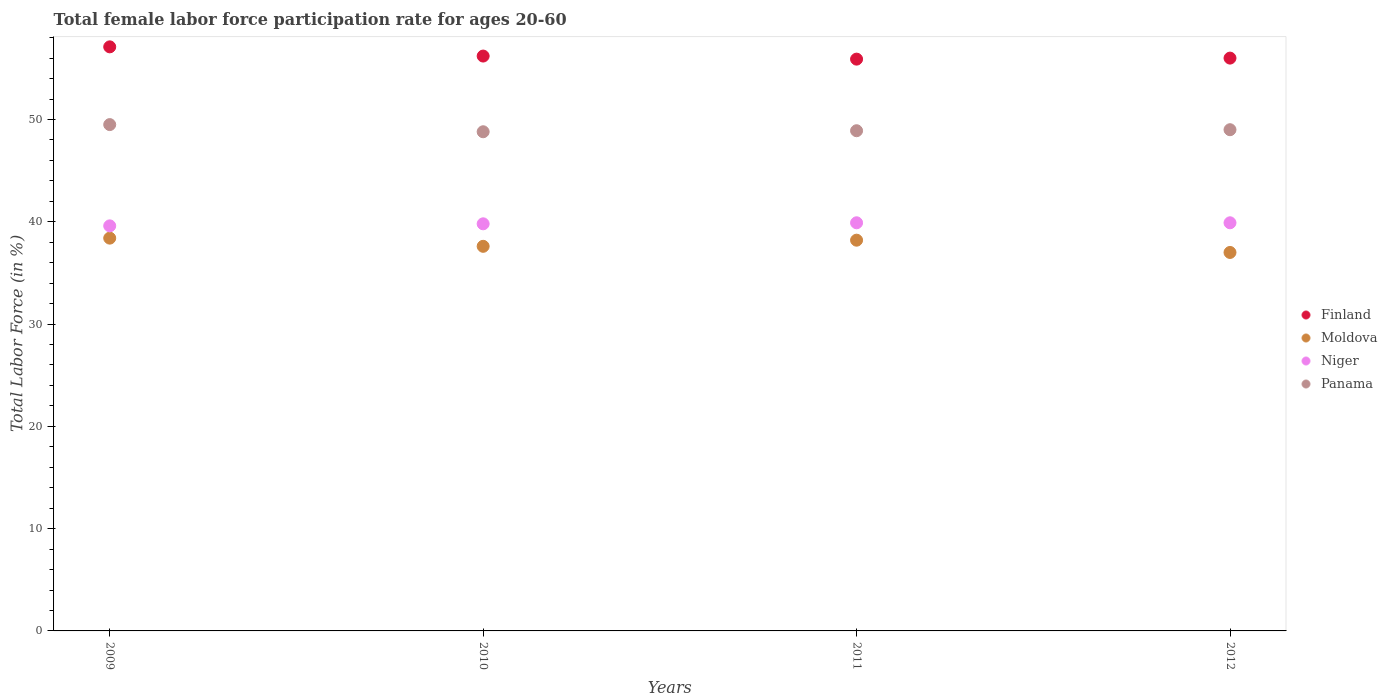Is the number of dotlines equal to the number of legend labels?
Ensure brevity in your answer.  Yes. Across all years, what is the maximum female labor force participation rate in Niger?
Give a very brief answer. 39.9. Across all years, what is the minimum female labor force participation rate in Panama?
Your answer should be very brief. 48.8. In which year was the female labor force participation rate in Niger minimum?
Make the answer very short. 2009. What is the total female labor force participation rate in Niger in the graph?
Offer a very short reply. 159.2. What is the difference between the female labor force participation rate in Moldova in 2009 and that in 2012?
Give a very brief answer. 1.4. What is the difference between the female labor force participation rate in Niger in 2011 and the female labor force participation rate in Finland in 2010?
Offer a terse response. -16.3. What is the average female labor force participation rate in Moldova per year?
Your answer should be compact. 37.8. In the year 2009, what is the difference between the female labor force participation rate in Moldova and female labor force participation rate in Finland?
Your answer should be very brief. -18.7. What is the ratio of the female labor force participation rate in Moldova in 2009 to that in 2011?
Your answer should be compact. 1.01. Is the difference between the female labor force participation rate in Moldova in 2010 and 2012 greater than the difference between the female labor force participation rate in Finland in 2010 and 2012?
Provide a short and direct response. Yes. What is the difference between the highest and the second highest female labor force participation rate in Finland?
Provide a short and direct response. 0.9. What is the difference between the highest and the lowest female labor force participation rate in Panama?
Provide a succinct answer. 0.7. In how many years, is the female labor force participation rate in Finland greater than the average female labor force participation rate in Finland taken over all years?
Offer a very short reply. 1. Is it the case that in every year, the sum of the female labor force participation rate in Finland and female labor force participation rate in Moldova  is greater than the sum of female labor force participation rate in Niger and female labor force participation rate in Panama?
Your response must be concise. No. Is it the case that in every year, the sum of the female labor force participation rate in Niger and female labor force participation rate in Panama  is greater than the female labor force participation rate in Finland?
Make the answer very short. Yes. Is the female labor force participation rate in Panama strictly less than the female labor force participation rate in Moldova over the years?
Your response must be concise. No. How many dotlines are there?
Ensure brevity in your answer.  4. Are the values on the major ticks of Y-axis written in scientific E-notation?
Ensure brevity in your answer.  No. Does the graph contain any zero values?
Give a very brief answer. No. Does the graph contain grids?
Ensure brevity in your answer.  No. Where does the legend appear in the graph?
Give a very brief answer. Center right. How are the legend labels stacked?
Give a very brief answer. Vertical. What is the title of the graph?
Offer a very short reply. Total female labor force participation rate for ages 20-60. Does "Upper middle income" appear as one of the legend labels in the graph?
Offer a terse response. No. What is the label or title of the Y-axis?
Your response must be concise. Total Labor Force (in %). What is the Total Labor Force (in %) in Finland in 2009?
Keep it short and to the point. 57.1. What is the Total Labor Force (in %) of Moldova in 2009?
Offer a very short reply. 38.4. What is the Total Labor Force (in %) of Niger in 2009?
Provide a succinct answer. 39.6. What is the Total Labor Force (in %) in Panama in 2009?
Provide a succinct answer. 49.5. What is the Total Labor Force (in %) in Finland in 2010?
Your answer should be compact. 56.2. What is the Total Labor Force (in %) of Moldova in 2010?
Keep it short and to the point. 37.6. What is the Total Labor Force (in %) in Niger in 2010?
Make the answer very short. 39.8. What is the Total Labor Force (in %) in Panama in 2010?
Your response must be concise. 48.8. What is the Total Labor Force (in %) in Finland in 2011?
Offer a terse response. 55.9. What is the Total Labor Force (in %) in Moldova in 2011?
Give a very brief answer. 38.2. What is the Total Labor Force (in %) of Niger in 2011?
Provide a short and direct response. 39.9. What is the Total Labor Force (in %) in Panama in 2011?
Your answer should be very brief. 48.9. What is the Total Labor Force (in %) of Finland in 2012?
Give a very brief answer. 56. What is the Total Labor Force (in %) of Moldova in 2012?
Offer a terse response. 37. What is the Total Labor Force (in %) in Niger in 2012?
Ensure brevity in your answer.  39.9. What is the Total Labor Force (in %) of Panama in 2012?
Ensure brevity in your answer.  49. Across all years, what is the maximum Total Labor Force (in %) of Finland?
Offer a terse response. 57.1. Across all years, what is the maximum Total Labor Force (in %) of Moldova?
Offer a terse response. 38.4. Across all years, what is the maximum Total Labor Force (in %) of Niger?
Your answer should be very brief. 39.9. Across all years, what is the maximum Total Labor Force (in %) in Panama?
Give a very brief answer. 49.5. Across all years, what is the minimum Total Labor Force (in %) of Finland?
Ensure brevity in your answer.  55.9. Across all years, what is the minimum Total Labor Force (in %) of Moldova?
Your response must be concise. 37. Across all years, what is the minimum Total Labor Force (in %) of Niger?
Your answer should be very brief. 39.6. Across all years, what is the minimum Total Labor Force (in %) in Panama?
Make the answer very short. 48.8. What is the total Total Labor Force (in %) of Finland in the graph?
Give a very brief answer. 225.2. What is the total Total Labor Force (in %) in Moldova in the graph?
Your answer should be compact. 151.2. What is the total Total Labor Force (in %) in Niger in the graph?
Offer a very short reply. 159.2. What is the total Total Labor Force (in %) of Panama in the graph?
Provide a short and direct response. 196.2. What is the difference between the Total Labor Force (in %) in Moldova in 2009 and that in 2010?
Make the answer very short. 0.8. What is the difference between the Total Labor Force (in %) of Panama in 2009 and that in 2010?
Your answer should be very brief. 0.7. What is the difference between the Total Labor Force (in %) of Niger in 2009 and that in 2011?
Offer a very short reply. -0.3. What is the difference between the Total Labor Force (in %) in Panama in 2009 and that in 2011?
Your answer should be compact. 0.6. What is the difference between the Total Labor Force (in %) in Finland in 2009 and that in 2012?
Provide a succinct answer. 1.1. What is the difference between the Total Labor Force (in %) in Niger in 2009 and that in 2012?
Keep it short and to the point. -0.3. What is the difference between the Total Labor Force (in %) in Panama in 2009 and that in 2012?
Keep it short and to the point. 0.5. What is the difference between the Total Labor Force (in %) in Finland in 2010 and that in 2011?
Make the answer very short. 0.3. What is the difference between the Total Labor Force (in %) of Moldova in 2010 and that in 2011?
Your answer should be compact. -0.6. What is the difference between the Total Labor Force (in %) in Finland in 2010 and that in 2012?
Give a very brief answer. 0.2. What is the difference between the Total Labor Force (in %) in Niger in 2010 and that in 2012?
Offer a very short reply. -0.1. What is the difference between the Total Labor Force (in %) of Finland in 2011 and that in 2012?
Your answer should be compact. -0.1. What is the difference between the Total Labor Force (in %) in Finland in 2009 and the Total Labor Force (in %) in Niger in 2011?
Offer a very short reply. 17.2. What is the difference between the Total Labor Force (in %) of Finland in 2009 and the Total Labor Force (in %) of Panama in 2011?
Your response must be concise. 8.2. What is the difference between the Total Labor Force (in %) in Niger in 2009 and the Total Labor Force (in %) in Panama in 2011?
Keep it short and to the point. -9.3. What is the difference between the Total Labor Force (in %) in Finland in 2009 and the Total Labor Force (in %) in Moldova in 2012?
Your answer should be compact. 20.1. What is the difference between the Total Labor Force (in %) of Moldova in 2009 and the Total Labor Force (in %) of Niger in 2012?
Give a very brief answer. -1.5. What is the difference between the Total Labor Force (in %) of Niger in 2009 and the Total Labor Force (in %) of Panama in 2012?
Offer a terse response. -9.4. What is the difference between the Total Labor Force (in %) of Finland in 2010 and the Total Labor Force (in %) of Moldova in 2011?
Your answer should be compact. 18. What is the difference between the Total Labor Force (in %) of Moldova in 2010 and the Total Labor Force (in %) of Niger in 2011?
Provide a succinct answer. -2.3. What is the difference between the Total Labor Force (in %) of Moldova in 2010 and the Total Labor Force (in %) of Panama in 2011?
Give a very brief answer. -11.3. What is the difference between the Total Labor Force (in %) of Finland in 2010 and the Total Labor Force (in %) of Niger in 2012?
Your response must be concise. 16.3. What is the difference between the Total Labor Force (in %) in Finland in 2010 and the Total Labor Force (in %) in Panama in 2012?
Make the answer very short. 7.2. What is the difference between the Total Labor Force (in %) in Moldova in 2011 and the Total Labor Force (in %) in Niger in 2012?
Offer a very short reply. -1.7. What is the difference between the Total Labor Force (in %) of Moldova in 2011 and the Total Labor Force (in %) of Panama in 2012?
Provide a succinct answer. -10.8. What is the average Total Labor Force (in %) of Finland per year?
Your answer should be compact. 56.3. What is the average Total Labor Force (in %) of Moldova per year?
Provide a succinct answer. 37.8. What is the average Total Labor Force (in %) of Niger per year?
Offer a terse response. 39.8. What is the average Total Labor Force (in %) of Panama per year?
Offer a terse response. 49.05. In the year 2009, what is the difference between the Total Labor Force (in %) of Finland and Total Labor Force (in %) of Niger?
Your answer should be very brief. 17.5. In the year 2009, what is the difference between the Total Labor Force (in %) of Finland and Total Labor Force (in %) of Panama?
Keep it short and to the point. 7.6. In the year 2009, what is the difference between the Total Labor Force (in %) of Moldova and Total Labor Force (in %) of Niger?
Your answer should be compact. -1.2. In the year 2009, what is the difference between the Total Labor Force (in %) in Moldova and Total Labor Force (in %) in Panama?
Offer a very short reply. -11.1. In the year 2010, what is the difference between the Total Labor Force (in %) in Finland and Total Labor Force (in %) in Moldova?
Your answer should be very brief. 18.6. In the year 2010, what is the difference between the Total Labor Force (in %) in Finland and Total Labor Force (in %) in Niger?
Ensure brevity in your answer.  16.4. In the year 2010, what is the difference between the Total Labor Force (in %) of Moldova and Total Labor Force (in %) of Niger?
Your response must be concise. -2.2. In the year 2011, what is the difference between the Total Labor Force (in %) in Finland and Total Labor Force (in %) in Niger?
Your response must be concise. 16. In the year 2011, what is the difference between the Total Labor Force (in %) in Finland and Total Labor Force (in %) in Panama?
Your response must be concise. 7. In the year 2011, what is the difference between the Total Labor Force (in %) of Moldova and Total Labor Force (in %) of Niger?
Ensure brevity in your answer.  -1.7. In the year 2011, what is the difference between the Total Labor Force (in %) of Niger and Total Labor Force (in %) of Panama?
Ensure brevity in your answer.  -9. In the year 2012, what is the difference between the Total Labor Force (in %) of Finland and Total Labor Force (in %) of Niger?
Your answer should be compact. 16.1. In the year 2012, what is the difference between the Total Labor Force (in %) in Moldova and Total Labor Force (in %) in Panama?
Keep it short and to the point. -12. What is the ratio of the Total Labor Force (in %) in Moldova in 2009 to that in 2010?
Your answer should be very brief. 1.02. What is the ratio of the Total Labor Force (in %) in Niger in 2009 to that in 2010?
Keep it short and to the point. 0.99. What is the ratio of the Total Labor Force (in %) in Panama in 2009 to that in 2010?
Ensure brevity in your answer.  1.01. What is the ratio of the Total Labor Force (in %) in Finland in 2009 to that in 2011?
Offer a terse response. 1.02. What is the ratio of the Total Labor Force (in %) of Moldova in 2009 to that in 2011?
Provide a succinct answer. 1.01. What is the ratio of the Total Labor Force (in %) of Panama in 2009 to that in 2011?
Keep it short and to the point. 1.01. What is the ratio of the Total Labor Force (in %) in Finland in 2009 to that in 2012?
Ensure brevity in your answer.  1.02. What is the ratio of the Total Labor Force (in %) of Moldova in 2009 to that in 2012?
Your answer should be compact. 1.04. What is the ratio of the Total Labor Force (in %) of Panama in 2009 to that in 2012?
Offer a terse response. 1.01. What is the ratio of the Total Labor Force (in %) of Finland in 2010 to that in 2011?
Ensure brevity in your answer.  1.01. What is the ratio of the Total Labor Force (in %) in Moldova in 2010 to that in 2011?
Your response must be concise. 0.98. What is the ratio of the Total Labor Force (in %) of Moldova in 2010 to that in 2012?
Provide a succinct answer. 1.02. What is the ratio of the Total Labor Force (in %) in Panama in 2010 to that in 2012?
Your answer should be very brief. 1. What is the ratio of the Total Labor Force (in %) of Finland in 2011 to that in 2012?
Provide a succinct answer. 1. What is the ratio of the Total Labor Force (in %) in Moldova in 2011 to that in 2012?
Your response must be concise. 1.03. What is the ratio of the Total Labor Force (in %) of Niger in 2011 to that in 2012?
Your answer should be very brief. 1. What is the difference between the highest and the lowest Total Labor Force (in %) of Moldova?
Provide a short and direct response. 1.4. What is the difference between the highest and the lowest Total Labor Force (in %) in Niger?
Your answer should be very brief. 0.3. What is the difference between the highest and the lowest Total Labor Force (in %) of Panama?
Provide a succinct answer. 0.7. 